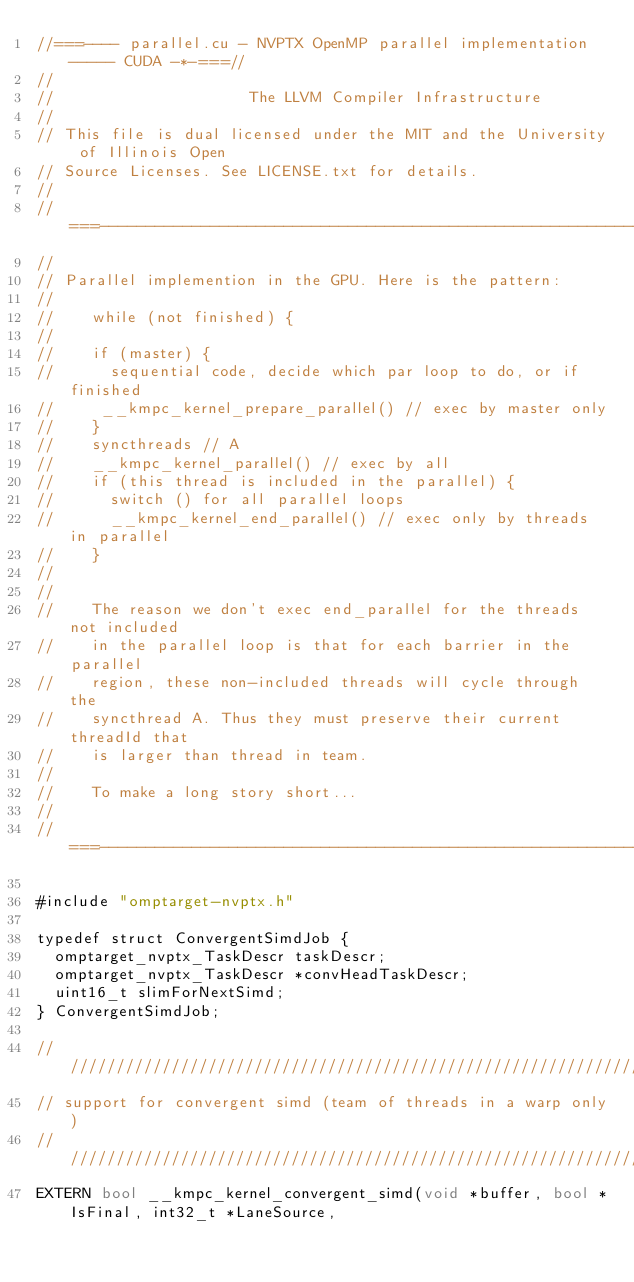<code> <loc_0><loc_0><loc_500><loc_500><_Cuda_>//===---- parallel.cu - NVPTX OpenMP parallel implementation ----- CUDA -*-===//
//
//                     The LLVM Compiler Infrastructure
//
// This file is dual licensed under the MIT and the University of Illinois Open
// Source Licenses. See LICENSE.txt for details.
//
//===----------------------------------------------------------------------===//
//
// Parallel implemention in the GPU. Here is the pattern:
//
//    while (not finished) {
//
//    if (master) {
//      sequential code, decide which par loop to do, or if finished
//     __kmpc_kernel_prepare_parallel() // exec by master only
//    }
//    syncthreads // A
//    __kmpc_kernel_parallel() // exec by all
//    if (this thread is included in the parallel) {
//      switch () for all parallel loops
//      __kmpc_kernel_end_parallel() // exec only by threads in parallel
//    }
//
//
//    The reason we don't exec end_parallel for the threads not included
//    in the parallel loop is that for each barrier in the parallel
//    region, these non-included threads will cycle through the
//    syncthread A. Thus they must preserve their current threadId that
//    is larger than thread in team.
//
//    To make a long story short...
//
//===----------------------------------------------------------------------===//

#include "omptarget-nvptx.h"

typedef struct ConvergentSimdJob {
  omptarget_nvptx_TaskDescr taskDescr;
  omptarget_nvptx_TaskDescr *convHeadTaskDescr;
  uint16_t slimForNextSimd;
} ConvergentSimdJob;

////////////////////////////////////////////////////////////////////////////////
// support for convergent simd (team of threads in a warp only)
////////////////////////////////////////////////////////////////////////////////
EXTERN bool __kmpc_kernel_convergent_simd(void *buffer, bool *IsFinal, int32_t *LaneSource,</code> 